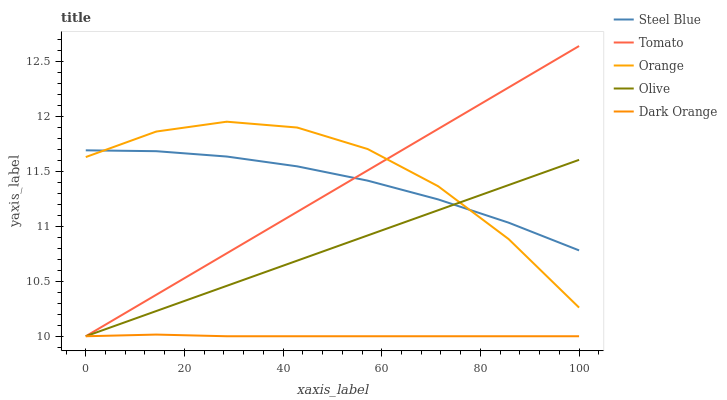Does Dark Orange have the minimum area under the curve?
Answer yes or no. Yes. Does Orange have the maximum area under the curve?
Answer yes or no. Yes. Does Steel Blue have the minimum area under the curve?
Answer yes or no. No. Does Steel Blue have the maximum area under the curve?
Answer yes or no. No. Is Tomato the smoothest?
Answer yes or no. Yes. Is Orange the roughest?
Answer yes or no. Yes. Is Steel Blue the smoothest?
Answer yes or no. No. Is Steel Blue the roughest?
Answer yes or no. No. Does Tomato have the lowest value?
Answer yes or no. Yes. Does Orange have the lowest value?
Answer yes or no. No. Does Tomato have the highest value?
Answer yes or no. Yes. Does Orange have the highest value?
Answer yes or no. No. Is Dark Orange less than Orange?
Answer yes or no. Yes. Is Steel Blue greater than Dark Orange?
Answer yes or no. Yes. Does Steel Blue intersect Orange?
Answer yes or no. Yes. Is Steel Blue less than Orange?
Answer yes or no. No. Is Steel Blue greater than Orange?
Answer yes or no. No. Does Dark Orange intersect Orange?
Answer yes or no. No. 